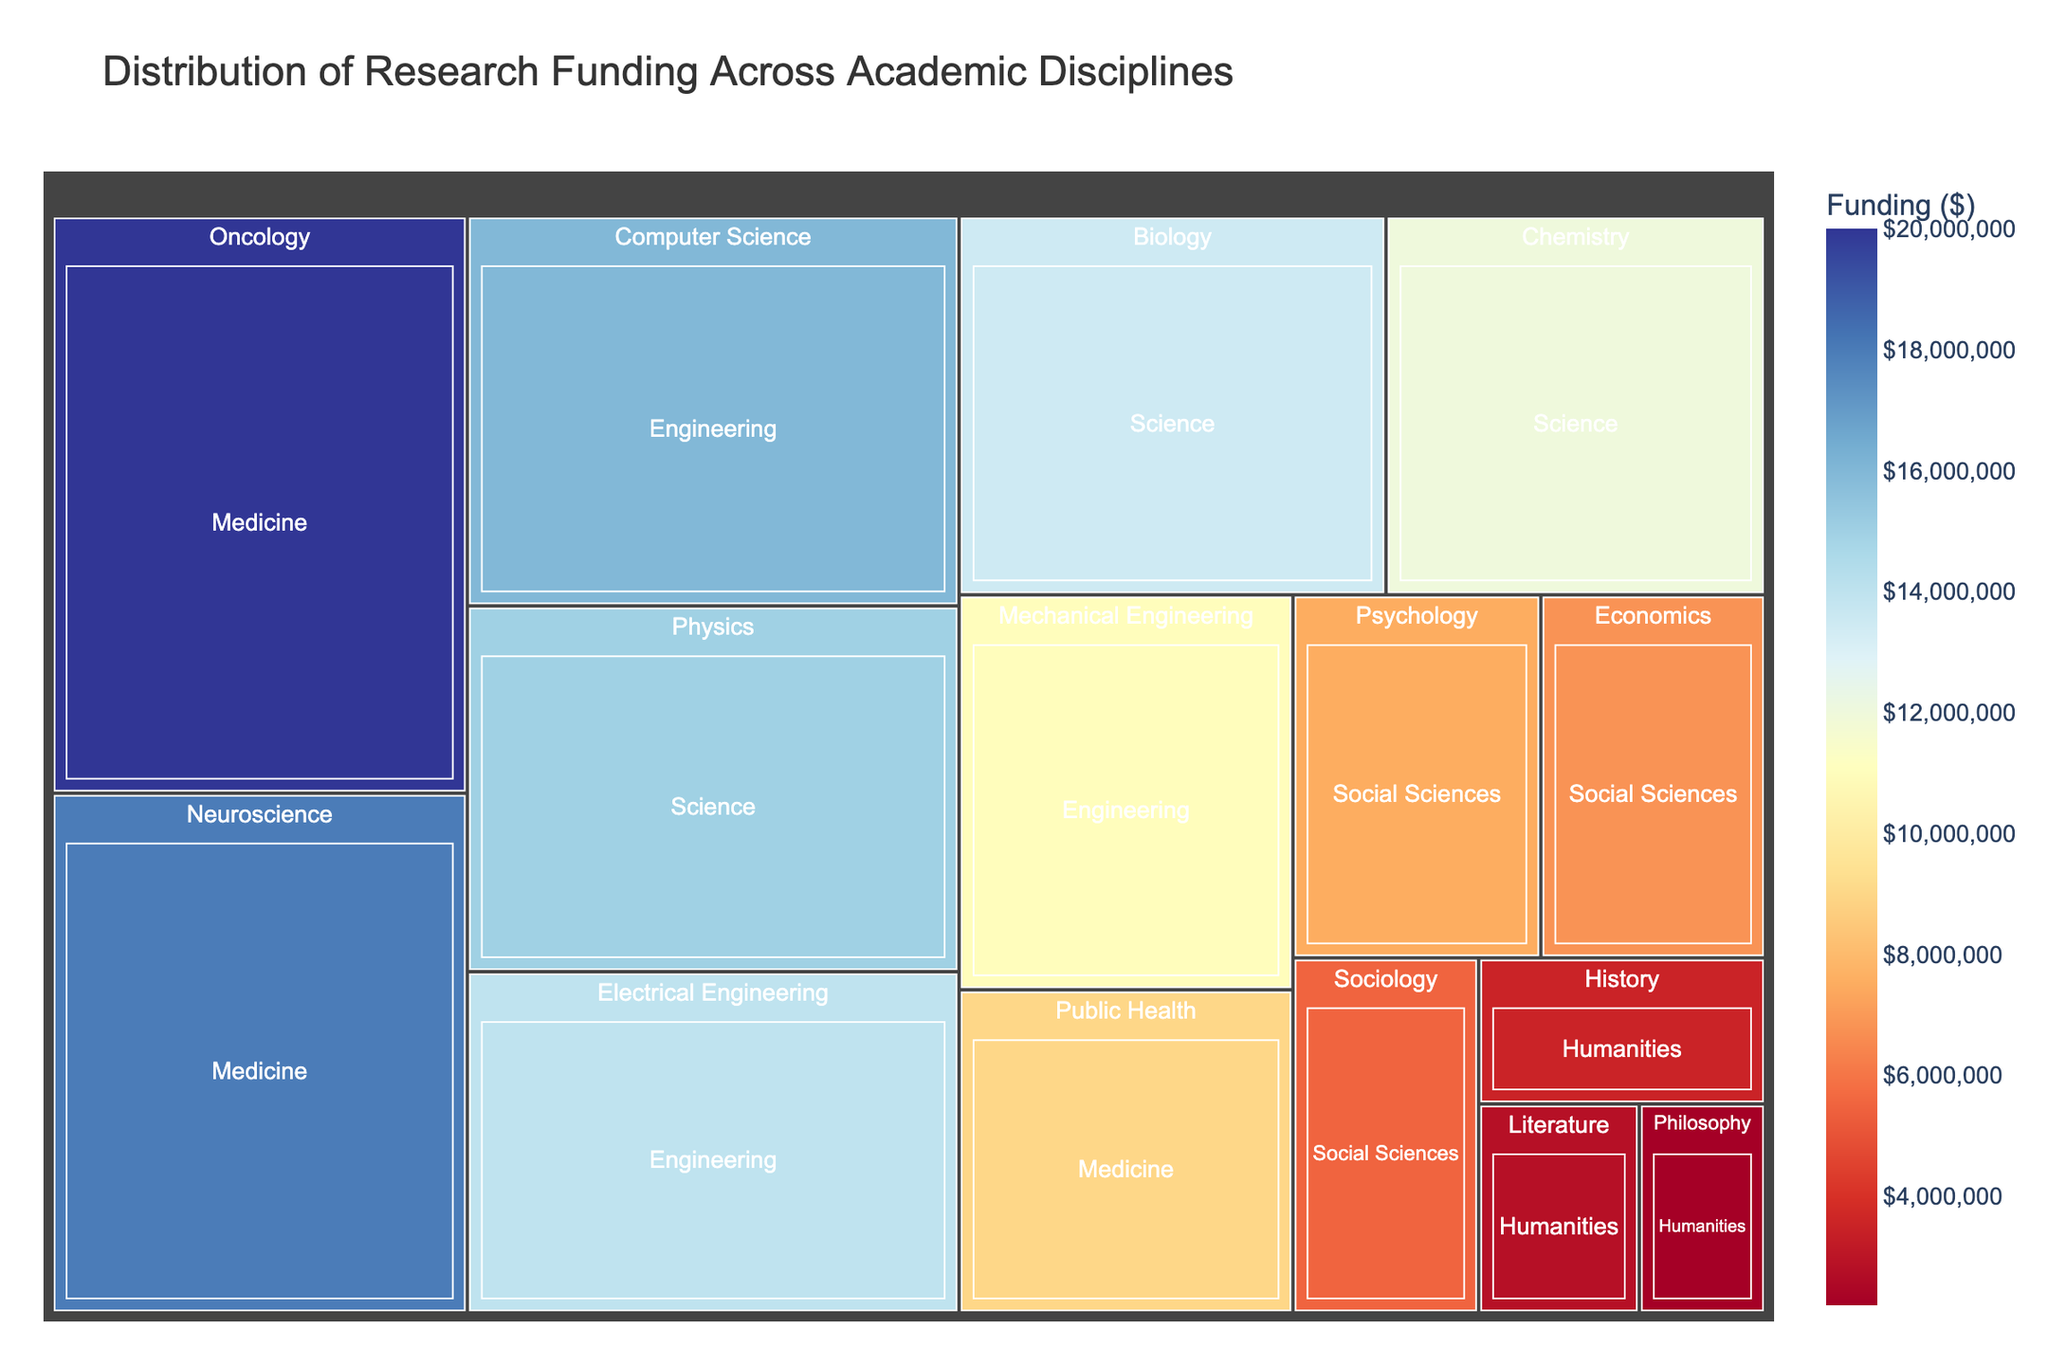What is the title of the treemap? The title is usually displayed prominently at the top of the figure. In this case, the title is "Distribution of Research Funding Across Academic Disciplines".
Answer: Distribution of Research Funding Across Academic Disciplines Which academic discipline received the most research funding? The largest segment in the treemap, often with the deepest color, represents the discipline with the most funding. Here, "Medicine" received the most funding.
Answer: Medicine What is the total amount of research funding for the Science and the Engineering departments combined? Combine the funding amounts for "Science" (Physics, Chemistry, Biology) and "Engineering" (Electrical Engineering, Mechanical Engineering, Computer Science). 15M + 12M + 13.5M + 14M + 11M + 16M = 81.5M.
Answer: $81,500,000 Which department within the Science field received the least funding? Look within the "Science" field in the treemap. "Chemistry" has the smallest block among Physics, Chemistry, and Biology.
Answer: Chemistry Compare the funding of the "History" department with the "Sociology" department. Which one has more funding? Identify and compare the sizes of the blocks for "History" and "Sociology". "History" received $3,500,000 whereas "Sociology" received $5,500,000.
Answer: Sociology Which department in the Social Sciences field has the highest funding? Among the blocks under the "Social Sciences" field, the largest one with the deepest color indicates the highest funding. "Psychology" has the highest funding.
Answer: Psychology What is the average funding for departments within the Humanities field? Sum the funding amounts of all Humanities departments (History, Literature, Philosophy) and divide by the number of departments. (3.5M + 2.8M + 2.2M) / 3 = 2.83M.
Answer: $2,833,333 How does the funding for Public Health compare to that of Chemistry? Compare the sizes and colors of the blocks for "Public Health" and "Chemistry". "Public Health" received $9M while "Chemistry" received $12M.
Answer: Chemistry received more What is the median funding amount for all the departments? Order the funding amounts for all departments and find the middle value. The sorted funding values are: 2.2M, 2.8M, 3.5M, 5.5M, 6.8M, 7.5M, 9M, 11M, 12M, 13.5M, 14M, 15M, 16M, 18M, 20M. The median is the 8th value.
Answer: $9,000,000 